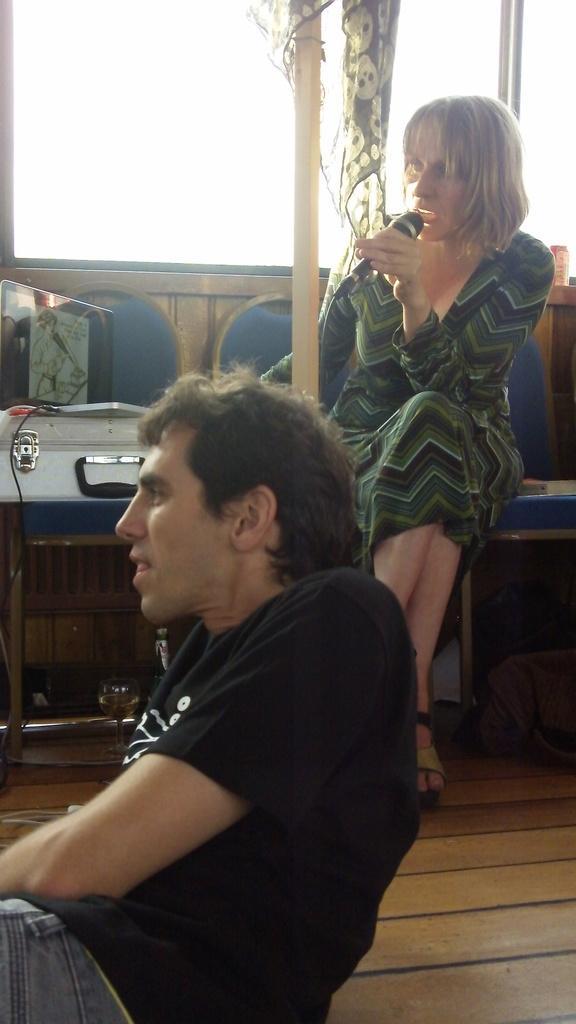Please provide a concise description of this image. In this image I can see a woman sitting on the chair and holding a microphone in her hand and another person wearing black colored t shirt is sitting on the floor. I can see a suitcase, a laptop on the suitcase, the window and the cloth. 